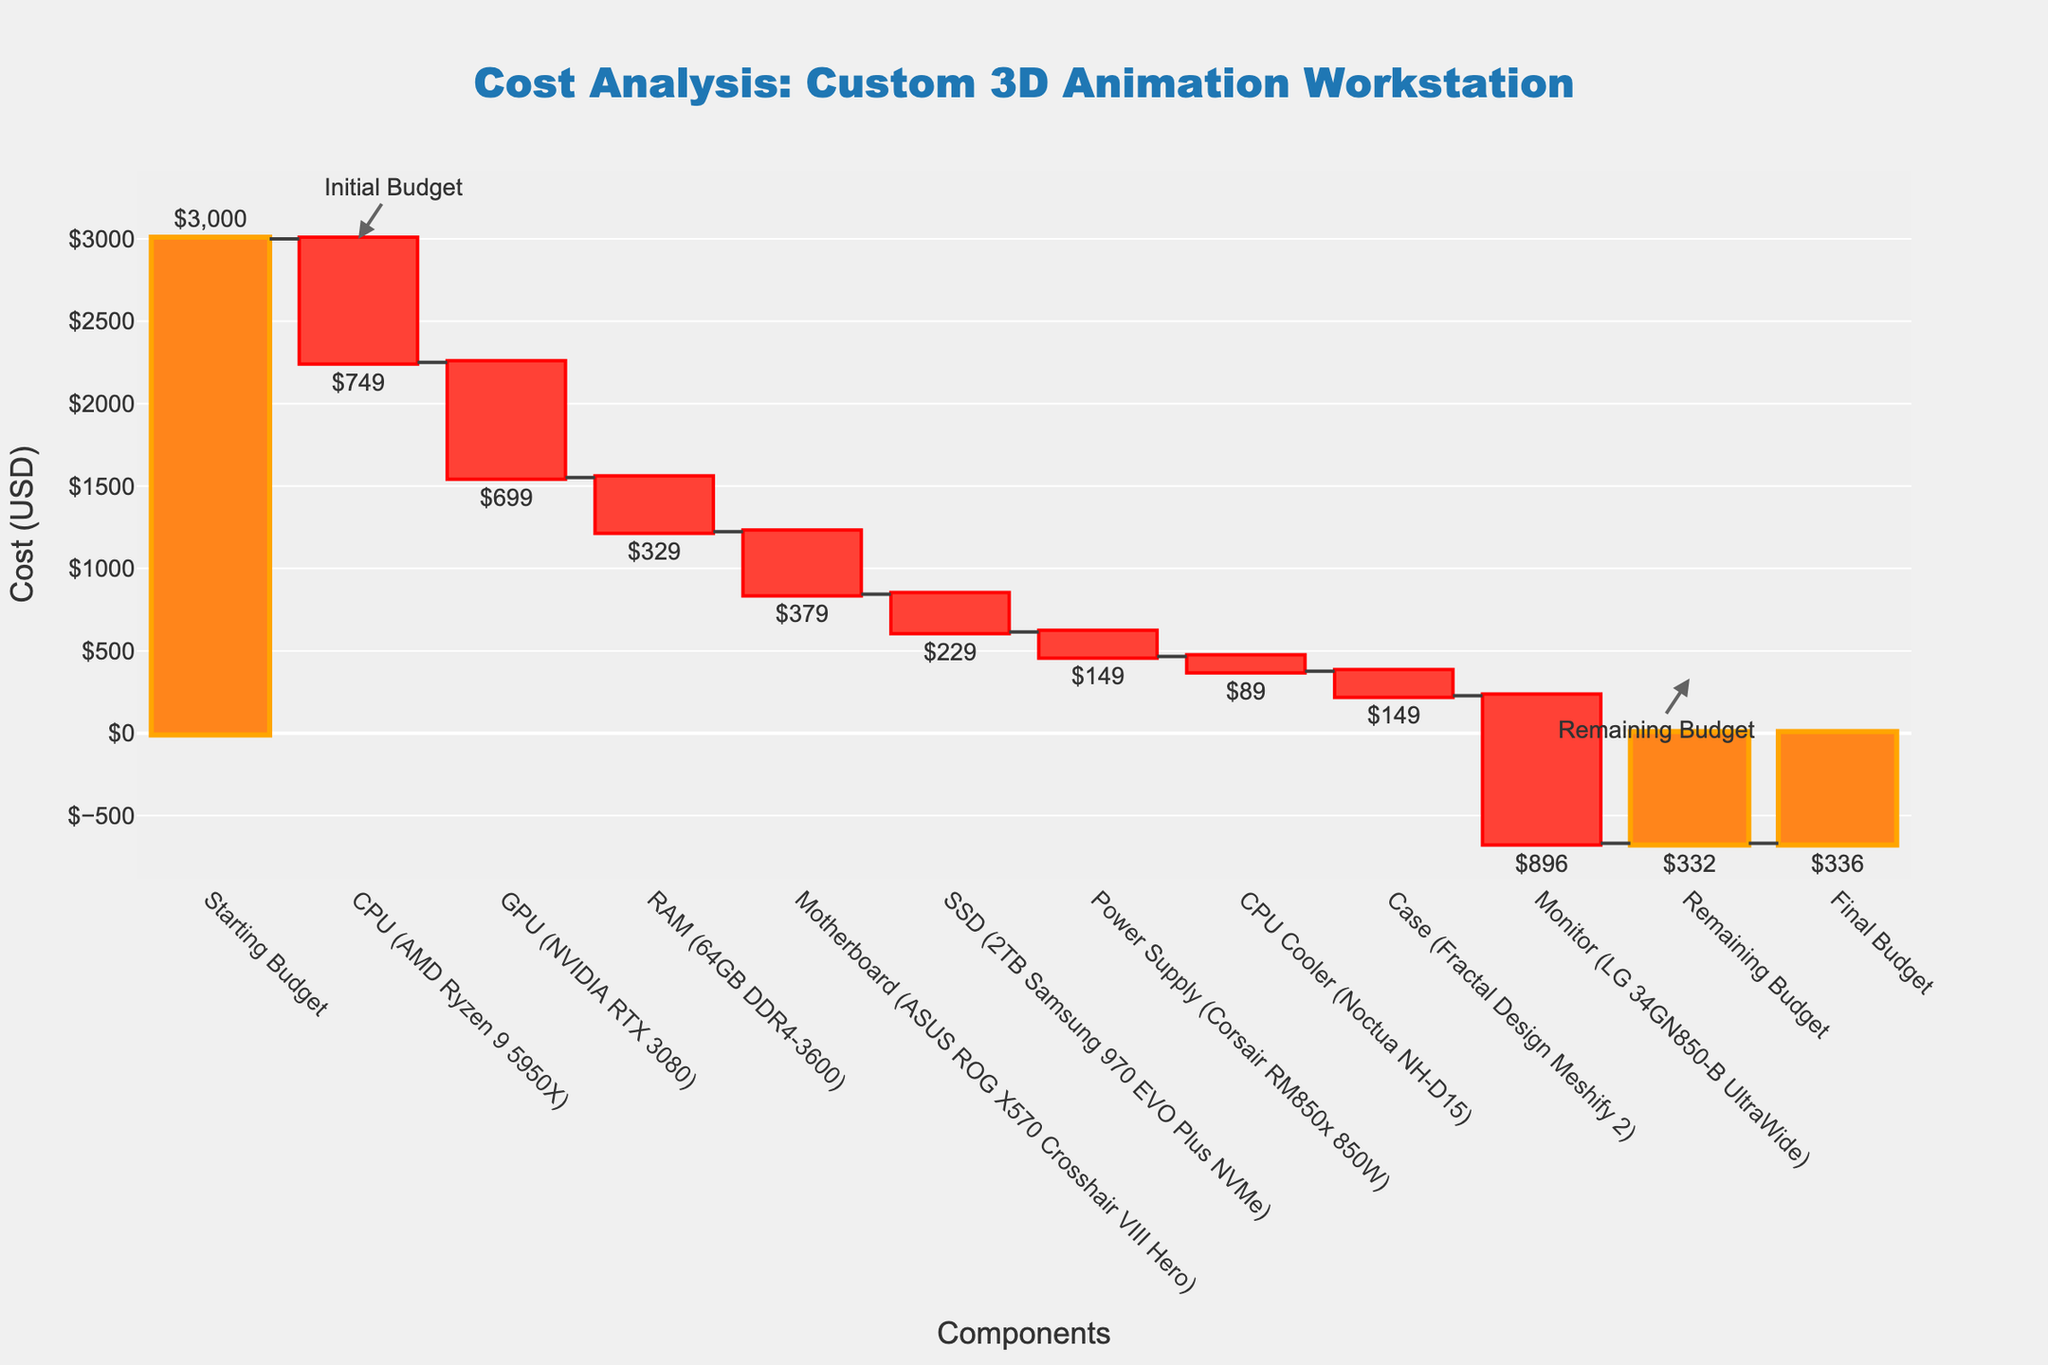How much was the initial budget? The initial budget is the amount listed under "Starting Budget" at the beginning of the waterfall chart.
Answer: $3,000 What component costs the most? To find the component that costs the most, look at the largest negative value in the chart, which is the one with the greatest downward bar.
Answer: Monitor (LG 34GN850-B UltraWide) How much is the remaining budget after purchasing all components? The remaining budget is shown at the end of the chart and it represents the final total after accounting for all costs.
Answer: $332 Which component has the second highest cost? To determine this, find the second largest negative value in the chart.
Answer: CPU (AMD Ryzen 9 5950X) How many components were purchased below $500? Count the components with costs less than $500 by examining the height of their respective bars.
Answer: 6 components (CPU Cooler, Case, Power Supply, SSD, RAM, Motherboard) Which component contributed the least to the overall cost? Identify the component with the smallest absolute value in costs by examining the height of the bars.
Answer: CPU Cooler (Noctua NH-D15) How much total money was spent on storage devices (SSD)? Identify the total spent on storage devices by looking at the cost of the SSD.
Answer: $229 By how much did the cost of the Power Supply affect the remaining budget? The cost of the Power Supply is a negative value, so it reduces the remaining budget by this amount.
Answer: $149 